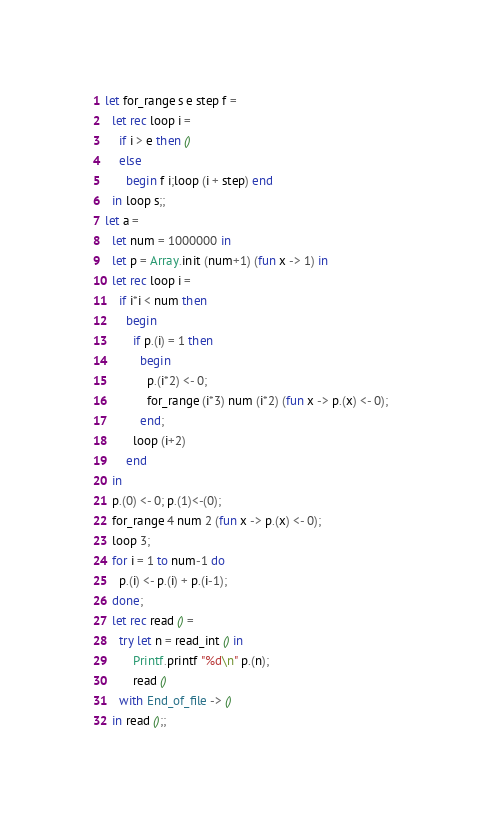<code> <loc_0><loc_0><loc_500><loc_500><_OCaml_>let for_range s e step f =
  let rec loop i =
    if i > e then ()
    else
      begin f i;loop (i + step) end
  in loop s;;
let a =
  let num = 1000000 in
  let p = Array.init (num+1) (fun x -> 1) in
  let rec loop i =
    if i*i < num then
      begin
        if p.(i) = 1 then
          begin
            p.(i*2) <- 0;
            for_range (i*3) num (i*2) (fun x -> p.(x) <- 0);
          end;
        loop (i+2)
      end
  in
  p.(0) <- 0; p.(1)<-(0);
  for_range 4 num 2 (fun x -> p.(x) <- 0);
  loop 3;
  for i = 1 to num-1 do
    p.(i) <- p.(i) + p.(i-1);
  done;
  let rec read () =
    try let n = read_int () in
        Printf.printf "%d\n" p.(n);
        read ()
    with End_of_file -> ()
  in read ();;</code> 